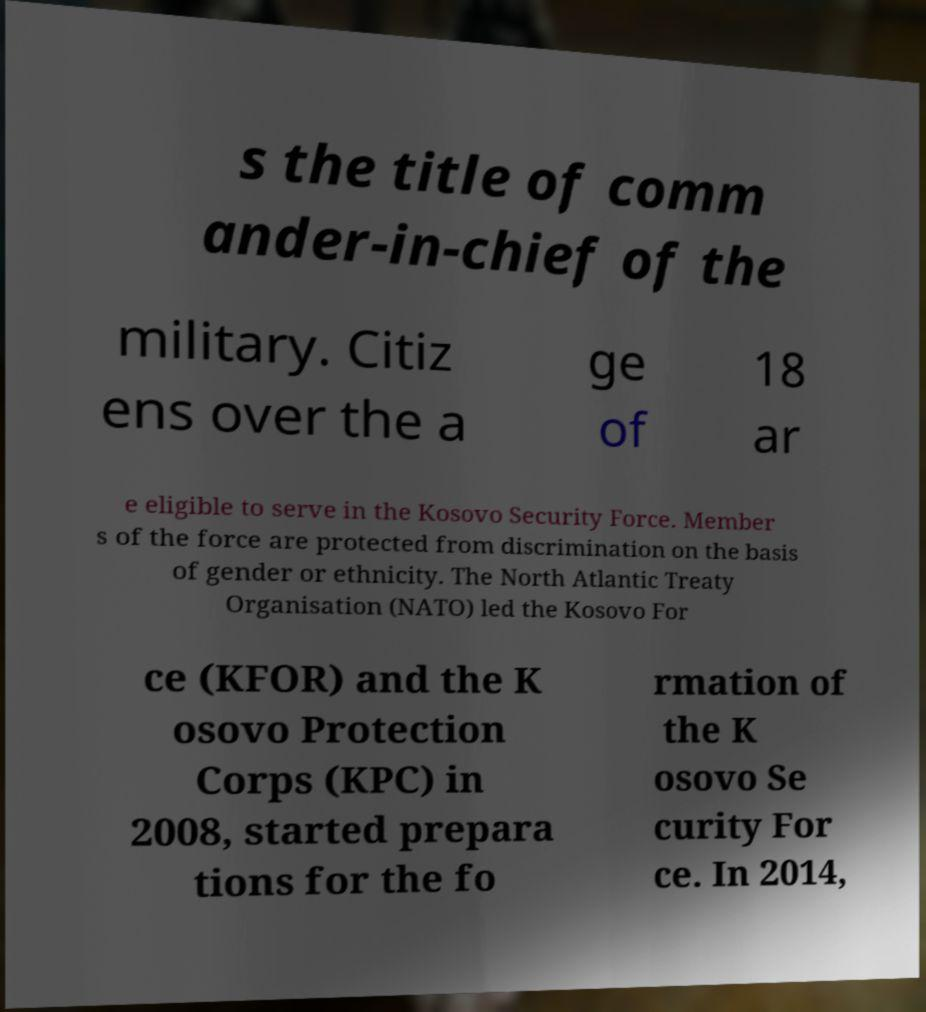There's text embedded in this image that I need extracted. Can you transcribe it verbatim? s the title of comm ander-in-chief of the military. Citiz ens over the a ge of 18 ar e eligible to serve in the Kosovo Security Force. Member s of the force are protected from discrimination on the basis of gender or ethnicity. The North Atlantic Treaty Organisation (NATO) led the Kosovo For ce (KFOR) and the K osovo Protection Corps (KPC) in 2008, started prepara tions for the fo rmation of the K osovo Se curity For ce. In 2014, 